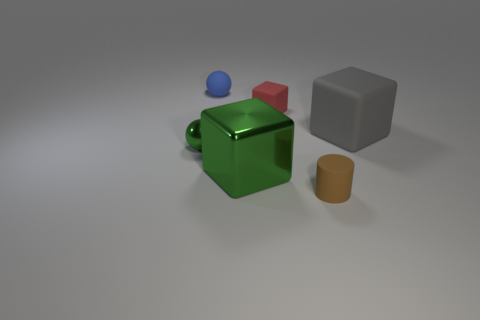What size is the cube that is the same color as the small shiny object?
Provide a short and direct response. Large. The small metallic thing that is the same color as the large metallic cube is what shape?
Provide a short and direct response. Sphere. Is there a small red cube that is behind the large object that is on the left side of the brown cylinder?
Make the answer very short. Yes. There is a ball that is behind the big gray block; what is it made of?
Make the answer very short. Rubber. Is the shape of the big green shiny thing the same as the small red rubber thing?
Your answer should be very brief. Yes. What color is the rubber cube that is on the left side of the rubber object in front of the tiny green sphere that is on the left side of the brown matte cylinder?
Offer a very short reply. Red. How many other large shiny things are the same shape as the large gray object?
Keep it short and to the point. 1. There is a green shiny object to the right of the green thing that is to the left of the blue thing; what is its size?
Offer a terse response. Large. Is the green metallic ball the same size as the gray object?
Offer a terse response. No. Are there any small balls that are in front of the tiny ball that is behind the rubber block that is left of the brown matte thing?
Offer a terse response. Yes. 